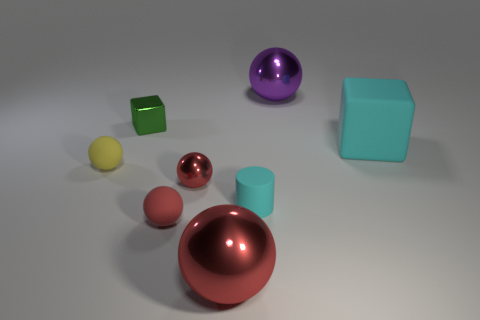There is a purple object that is the same size as the cyan matte cube; what shape is it? The purple object of identical size to the cyan matte cube is a sphere, exhibiting a smooth and continuous surface with a glossy finish that contrasts the cube's flat sides and matte texture. 